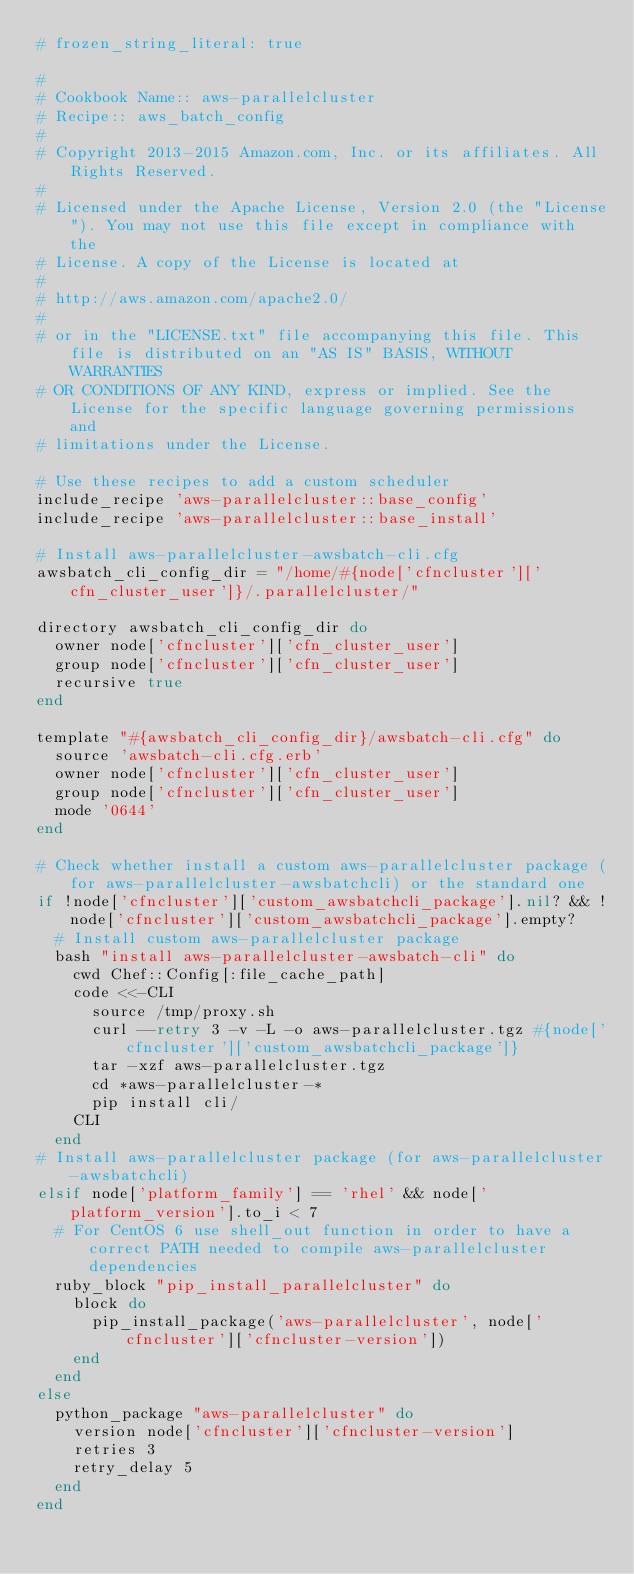<code> <loc_0><loc_0><loc_500><loc_500><_Ruby_># frozen_string_literal: true

#
# Cookbook Name:: aws-parallelcluster
# Recipe:: aws_batch_config
#
# Copyright 2013-2015 Amazon.com, Inc. or its affiliates. All Rights Reserved.
#
# Licensed under the Apache License, Version 2.0 (the "License"). You may not use this file except in compliance with the
# License. A copy of the License is located at
#
# http://aws.amazon.com/apache2.0/
#
# or in the "LICENSE.txt" file accompanying this file. This file is distributed on an "AS IS" BASIS, WITHOUT WARRANTIES
# OR CONDITIONS OF ANY KIND, express or implied. See the License for the specific language governing permissions and
# limitations under the License.

# Use these recipes to add a custom scheduler
include_recipe 'aws-parallelcluster::base_config'
include_recipe 'aws-parallelcluster::base_install'

# Install aws-parallelcluster-awsbatch-cli.cfg
awsbatch_cli_config_dir = "/home/#{node['cfncluster']['cfn_cluster_user']}/.parallelcluster/"

directory awsbatch_cli_config_dir do
  owner node['cfncluster']['cfn_cluster_user']
  group node['cfncluster']['cfn_cluster_user']
  recursive true
end

template "#{awsbatch_cli_config_dir}/awsbatch-cli.cfg" do
  source 'awsbatch-cli.cfg.erb'
  owner node['cfncluster']['cfn_cluster_user']
  group node['cfncluster']['cfn_cluster_user']
  mode '0644'
end

# Check whether install a custom aws-parallelcluster package (for aws-parallelcluster-awsbatchcli) or the standard one
if !node['cfncluster']['custom_awsbatchcli_package'].nil? && !node['cfncluster']['custom_awsbatchcli_package'].empty?
  # Install custom aws-parallelcluster package
  bash "install aws-parallelcluster-awsbatch-cli" do
    cwd Chef::Config[:file_cache_path]
    code <<-CLI
      source /tmp/proxy.sh
      curl --retry 3 -v -L -o aws-parallelcluster.tgz #{node['cfncluster']['custom_awsbatchcli_package']}
      tar -xzf aws-parallelcluster.tgz
      cd *aws-parallelcluster-*
      pip install cli/
    CLI
  end
# Install aws-parallelcluster package (for aws-parallelcluster-awsbatchcli)
elsif node['platform_family'] == 'rhel' && node['platform_version'].to_i < 7
  # For CentOS 6 use shell_out function in order to have a correct PATH needed to compile aws-parallelcluster dependencies
  ruby_block "pip_install_parallelcluster" do
    block do
      pip_install_package('aws-parallelcluster', node['cfncluster']['cfncluster-version'])
    end
  end
else
  python_package "aws-parallelcluster" do
    version node['cfncluster']['cfncluster-version']
    retries 3
    retry_delay 5
  end
end
</code> 